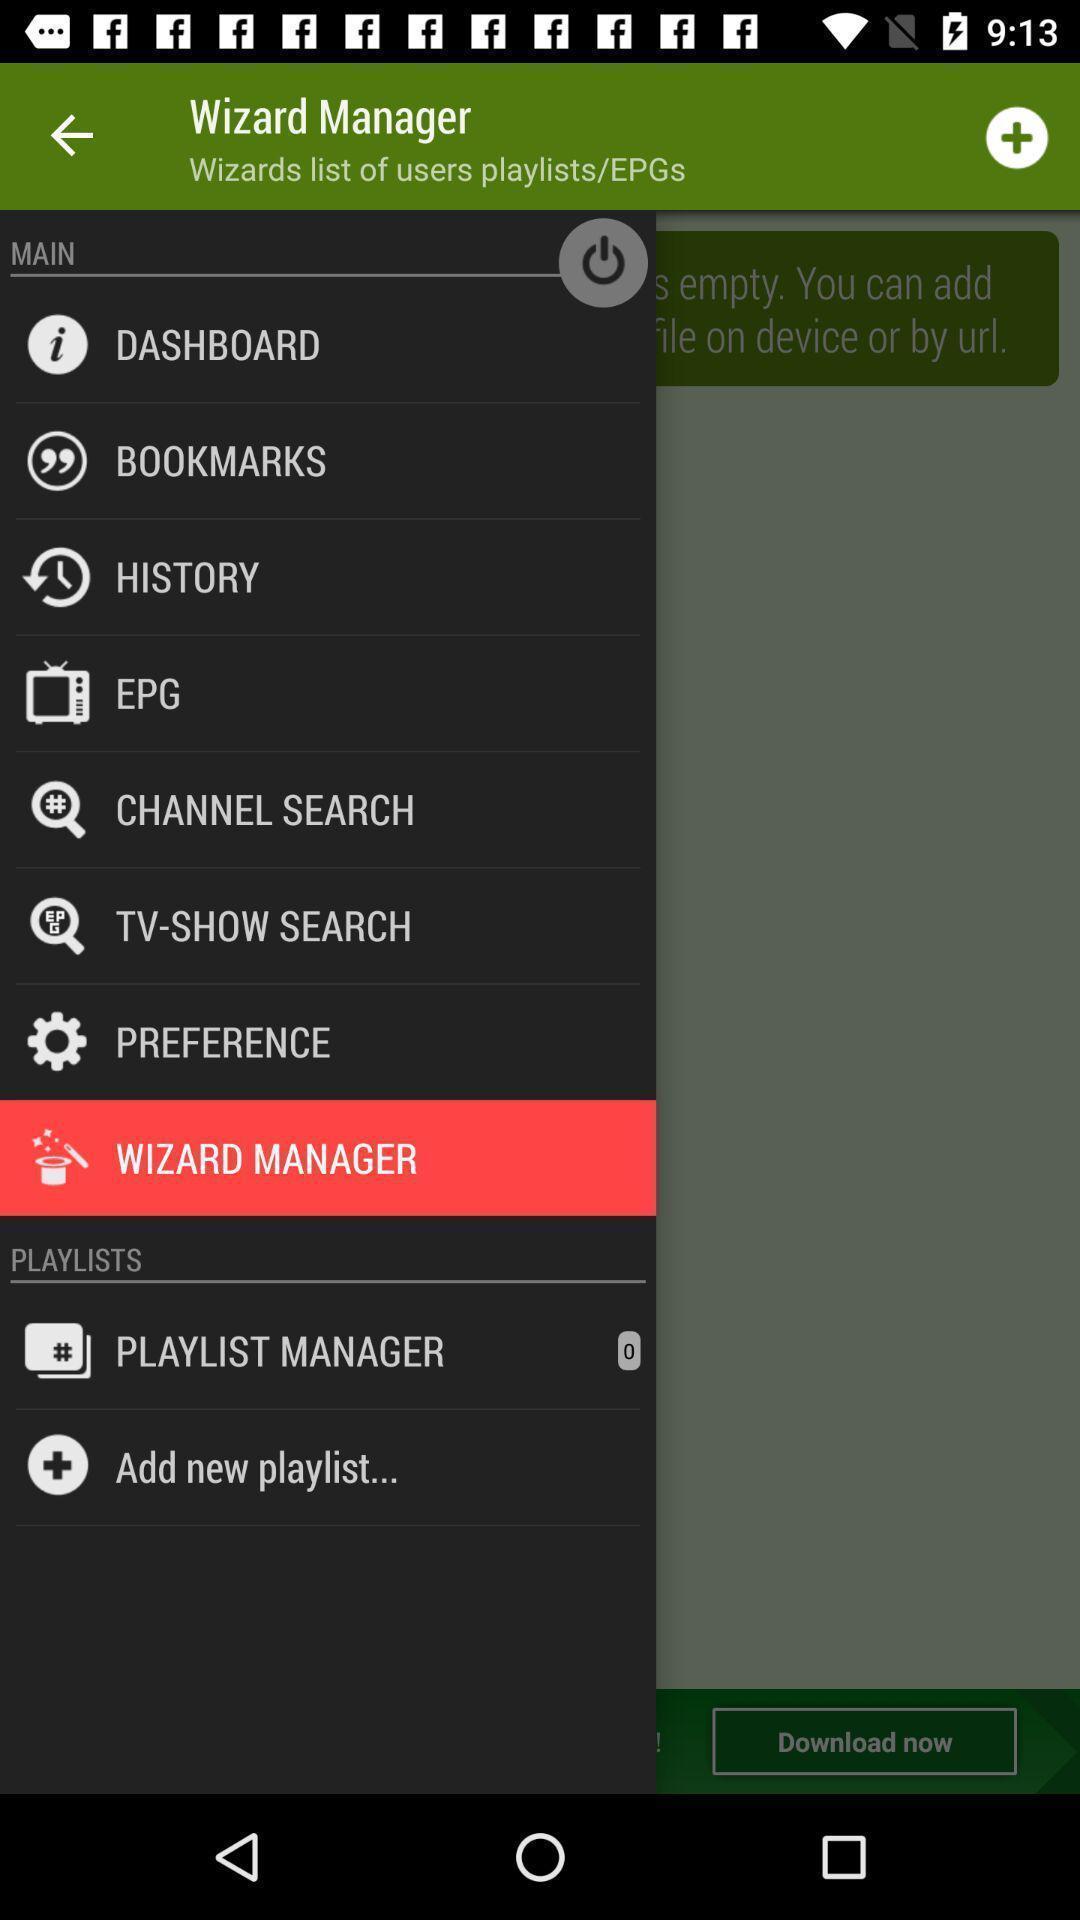Describe the key features of this screenshot. Wizard manager page. 